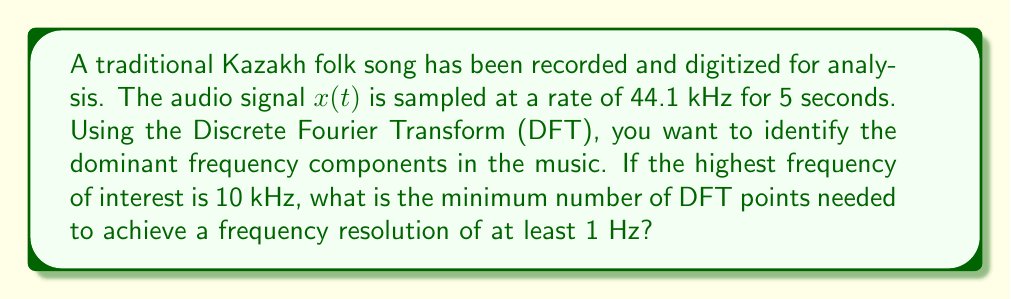Could you help me with this problem? To solve this problem, we need to consider the following steps:

1. Determine the total number of samples:
   The sampling rate is 44.1 kHz and the duration is 5 seconds.
   Total samples = $44100 \text{ samples/s} \times 5 \text{ s} = 220500 \text{ samples}$

2. Calculate the frequency resolution:
   The frequency resolution of the DFT is given by:
   $$\Delta f = \frac{f_s}{N}$$
   Where $f_s$ is the sampling frequency and $N$ is the number of DFT points.

3. We want $\Delta f \leq 1 \text{ Hz}$, so:
   $$1 \text{ Hz} \geq \frac{44100 \text{ Hz}}{N}$$

4. Solve for $N$:
   $$N \geq 44100$$

5. The number of DFT points must be a power of 2 for efficient computation using the Fast Fourier Transform (FFT) algorithm. So, we need to find the smallest power of 2 that is greater than or equal to 44100.

6. The next power of 2 after 44100 is $2^{16} = 65536$.

Therefore, the minimum number of DFT points needed is 65536.

Note: This number of points will provide a frequency resolution of:
$$\Delta f = \frac{44100 \text{ Hz}}{65536} \approx 0.67 \text{ Hz}$$
Which is better than the required 1 Hz resolution.
Answer: 65536 DFT points 